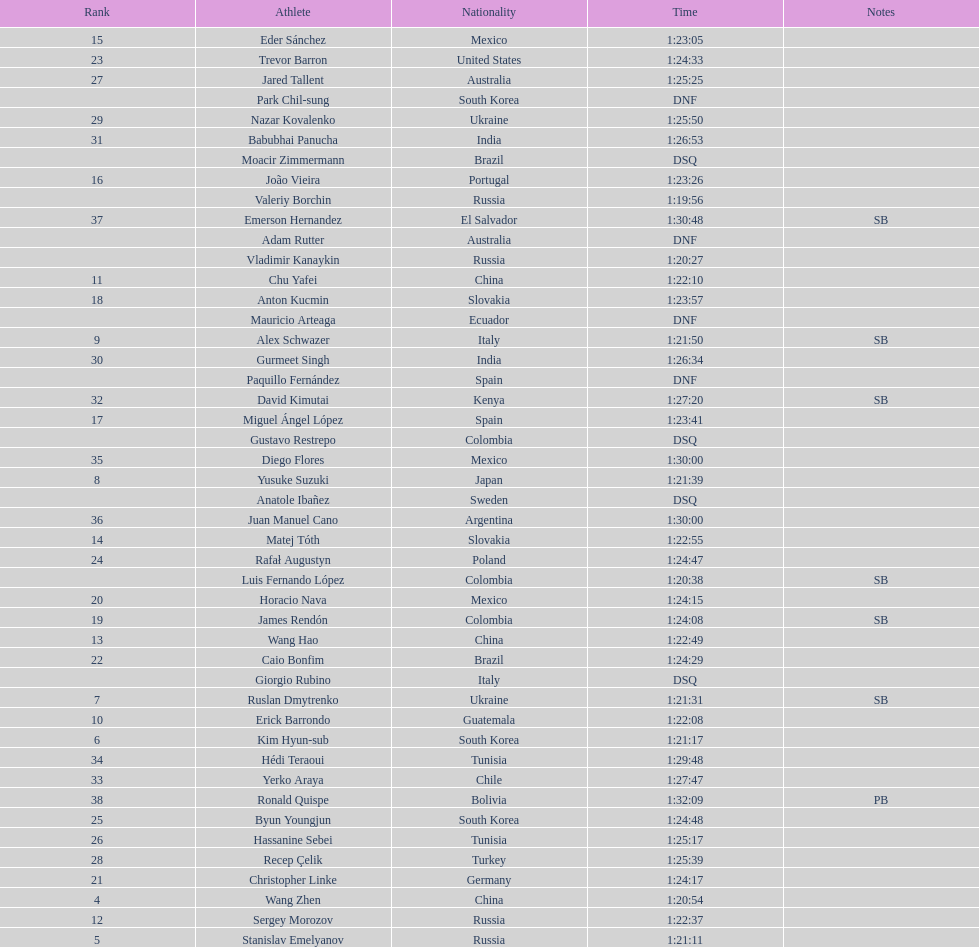Which chinese athlete had the fastest time? Wang Zhen. 